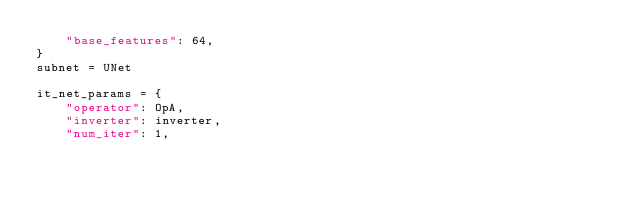Convert code to text. <code><loc_0><loc_0><loc_500><loc_500><_Python_>    "base_features": 64,
}
subnet = UNet

it_net_params = {
    "operator": OpA,
    "inverter": inverter,
    "num_iter": 1,</code> 